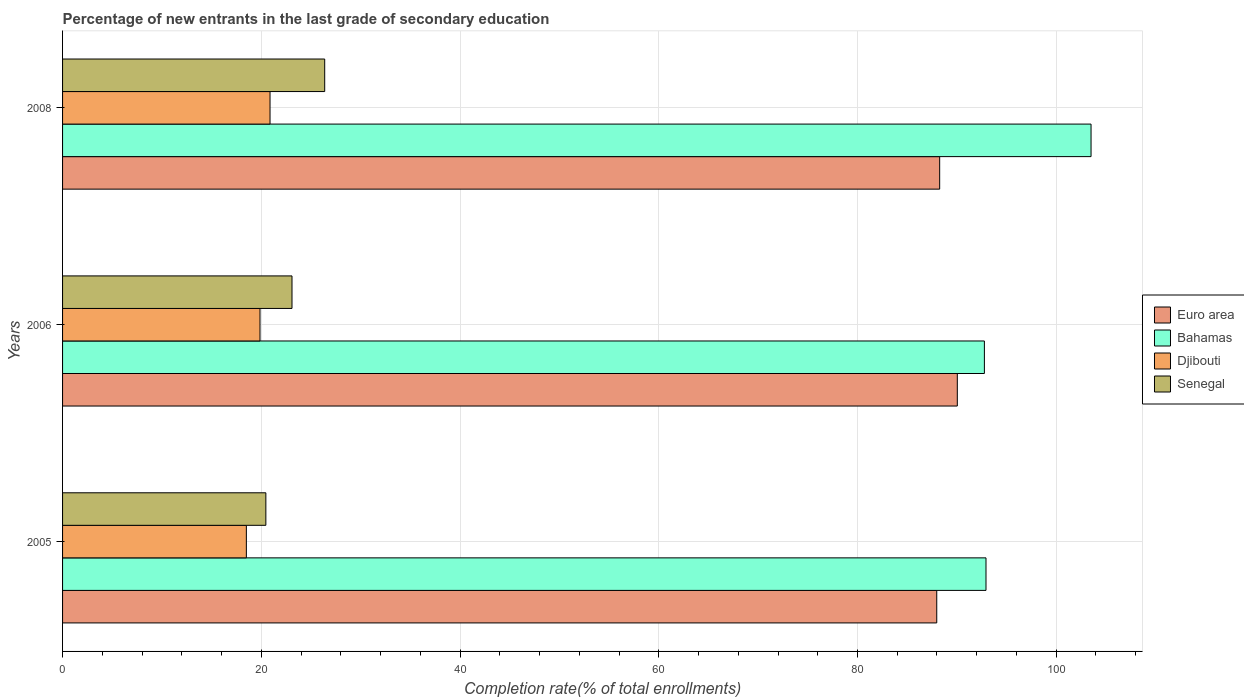How many different coloured bars are there?
Make the answer very short. 4. How many groups of bars are there?
Your response must be concise. 3. Are the number of bars per tick equal to the number of legend labels?
Offer a very short reply. Yes. Are the number of bars on each tick of the Y-axis equal?
Provide a succinct answer. Yes. How many bars are there on the 1st tick from the top?
Provide a short and direct response. 4. How many bars are there on the 3rd tick from the bottom?
Provide a short and direct response. 4. What is the percentage of new entrants in Euro area in 2005?
Give a very brief answer. 87.98. Across all years, what is the maximum percentage of new entrants in Djibouti?
Your response must be concise. 20.88. Across all years, what is the minimum percentage of new entrants in Euro area?
Give a very brief answer. 87.98. What is the total percentage of new entrants in Senegal in the graph?
Keep it short and to the point. 69.93. What is the difference between the percentage of new entrants in Euro area in 2005 and that in 2008?
Ensure brevity in your answer.  -0.29. What is the difference between the percentage of new entrants in Euro area in 2006 and the percentage of new entrants in Djibouti in 2005?
Ensure brevity in your answer.  71.55. What is the average percentage of new entrants in Senegal per year?
Provide a succinct answer. 23.31. In the year 2006, what is the difference between the percentage of new entrants in Euro area and percentage of new entrants in Bahamas?
Give a very brief answer. -2.73. What is the ratio of the percentage of new entrants in Djibouti in 2006 to that in 2008?
Your answer should be compact. 0.95. What is the difference between the highest and the second highest percentage of new entrants in Bahamas?
Keep it short and to the point. 10.57. What is the difference between the highest and the lowest percentage of new entrants in Senegal?
Your response must be concise. 5.92. Is the sum of the percentage of new entrants in Bahamas in 2005 and 2008 greater than the maximum percentage of new entrants in Euro area across all years?
Provide a short and direct response. Yes. Is it the case that in every year, the sum of the percentage of new entrants in Euro area and percentage of new entrants in Senegal is greater than the sum of percentage of new entrants in Bahamas and percentage of new entrants in Djibouti?
Keep it short and to the point. No. What does the 4th bar from the top in 2005 represents?
Offer a terse response. Euro area. What does the 4th bar from the bottom in 2005 represents?
Offer a very short reply. Senegal. How many bars are there?
Keep it short and to the point. 12. Are all the bars in the graph horizontal?
Your answer should be compact. Yes. How many years are there in the graph?
Keep it short and to the point. 3. Where does the legend appear in the graph?
Offer a terse response. Center right. How are the legend labels stacked?
Your response must be concise. Vertical. What is the title of the graph?
Your answer should be very brief. Percentage of new entrants in the last grade of secondary education. What is the label or title of the X-axis?
Your response must be concise. Completion rate(% of total enrollments). What is the label or title of the Y-axis?
Offer a terse response. Years. What is the Completion rate(% of total enrollments) of Euro area in 2005?
Keep it short and to the point. 87.98. What is the Completion rate(% of total enrollments) of Bahamas in 2005?
Your answer should be compact. 92.93. What is the Completion rate(% of total enrollments) in Djibouti in 2005?
Provide a succinct answer. 18.5. What is the Completion rate(% of total enrollments) of Senegal in 2005?
Make the answer very short. 20.46. What is the Completion rate(% of total enrollments) in Euro area in 2006?
Your answer should be very brief. 90.04. What is the Completion rate(% of total enrollments) of Bahamas in 2006?
Provide a short and direct response. 92.77. What is the Completion rate(% of total enrollments) of Djibouti in 2006?
Make the answer very short. 19.87. What is the Completion rate(% of total enrollments) of Senegal in 2006?
Give a very brief answer. 23.09. What is the Completion rate(% of total enrollments) of Euro area in 2008?
Make the answer very short. 88.27. What is the Completion rate(% of total enrollments) in Bahamas in 2008?
Offer a very short reply. 103.5. What is the Completion rate(% of total enrollments) in Djibouti in 2008?
Offer a very short reply. 20.88. What is the Completion rate(% of total enrollments) in Senegal in 2008?
Your answer should be compact. 26.38. Across all years, what is the maximum Completion rate(% of total enrollments) of Euro area?
Make the answer very short. 90.04. Across all years, what is the maximum Completion rate(% of total enrollments) in Bahamas?
Offer a very short reply. 103.5. Across all years, what is the maximum Completion rate(% of total enrollments) in Djibouti?
Provide a short and direct response. 20.88. Across all years, what is the maximum Completion rate(% of total enrollments) of Senegal?
Make the answer very short. 26.38. Across all years, what is the minimum Completion rate(% of total enrollments) in Euro area?
Provide a short and direct response. 87.98. Across all years, what is the minimum Completion rate(% of total enrollments) of Bahamas?
Give a very brief answer. 92.77. Across all years, what is the minimum Completion rate(% of total enrollments) in Djibouti?
Keep it short and to the point. 18.5. Across all years, what is the minimum Completion rate(% of total enrollments) in Senegal?
Keep it short and to the point. 20.46. What is the total Completion rate(% of total enrollments) in Euro area in the graph?
Give a very brief answer. 266.29. What is the total Completion rate(% of total enrollments) of Bahamas in the graph?
Your response must be concise. 289.21. What is the total Completion rate(% of total enrollments) of Djibouti in the graph?
Keep it short and to the point. 59.25. What is the total Completion rate(% of total enrollments) in Senegal in the graph?
Your answer should be very brief. 69.93. What is the difference between the Completion rate(% of total enrollments) of Euro area in 2005 and that in 2006?
Offer a terse response. -2.07. What is the difference between the Completion rate(% of total enrollments) in Bahamas in 2005 and that in 2006?
Offer a terse response. 0.16. What is the difference between the Completion rate(% of total enrollments) of Djibouti in 2005 and that in 2006?
Keep it short and to the point. -1.37. What is the difference between the Completion rate(% of total enrollments) of Senegal in 2005 and that in 2006?
Offer a very short reply. -2.63. What is the difference between the Completion rate(% of total enrollments) in Euro area in 2005 and that in 2008?
Offer a terse response. -0.29. What is the difference between the Completion rate(% of total enrollments) of Bahamas in 2005 and that in 2008?
Make the answer very short. -10.57. What is the difference between the Completion rate(% of total enrollments) in Djibouti in 2005 and that in 2008?
Your answer should be very brief. -2.38. What is the difference between the Completion rate(% of total enrollments) of Senegal in 2005 and that in 2008?
Your response must be concise. -5.92. What is the difference between the Completion rate(% of total enrollments) in Euro area in 2006 and that in 2008?
Provide a succinct answer. 1.77. What is the difference between the Completion rate(% of total enrollments) of Bahamas in 2006 and that in 2008?
Offer a terse response. -10.73. What is the difference between the Completion rate(% of total enrollments) in Djibouti in 2006 and that in 2008?
Provide a succinct answer. -1.01. What is the difference between the Completion rate(% of total enrollments) of Senegal in 2006 and that in 2008?
Your answer should be very brief. -3.29. What is the difference between the Completion rate(% of total enrollments) of Euro area in 2005 and the Completion rate(% of total enrollments) of Bahamas in 2006?
Provide a succinct answer. -4.79. What is the difference between the Completion rate(% of total enrollments) in Euro area in 2005 and the Completion rate(% of total enrollments) in Djibouti in 2006?
Make the answer very short. 68.11. What is the difference between the Completion rate(% of total enrollments) in Euro area in 2005 and the Completion rate(% of total enrollments) in Senegal in 2006?
Your answer should be compact. 64.89. What is the difference between the Completion rate(% of total enrollments) of Bahamas in 2005 and the Completion rate(% of total enrollments) of Djibouti in 2006?
Offer a very short reply. 73.06. What is the difference between the Completion rate(% of total enrollments) in Bahamas in 2005 and the Completion rate(% of total enrollments) in Senegal in 2006?
Offer a very short reply. 69.84. What is the difference between the Completion rate(% of total enrollments) in Djibouti in 2005 and the Completion rate(% of total enrollments) in Senegal in 2006?
Your response must be concise. -4.59. What is the difference between the Completion rate(% of total enrollments) of Euro area in 2005 and the Completion rate(% of total enrollments) of Bahamas in 2008?
Make the answer very short. -15.53. What is the difference between the Completion rate(% of total enrollments) of Euro area in 2005 and the Completion rate(% of total enrollments) of Djibouti in 2008?
Your answer should be very brief. 67.1. What is the difference between the Completion rate(% of total enrollments) of Euro area in 2005 and the Completion rate(% of total enrollments) of Senegal in 2008?
Offer a very short reply. 61.6. What is the difference between the Completion rate(% of total enrollments) in Bahamas in 2005 and the Completion rate(% of total enrollments) in Djibouti in 2008?
Make the answer very short. 72.05. What is the difference between the Completion rate(% of total enrollments) of Bahamas in 2005 and the Completion rate(% of total enrollments) of Senegal in 2008?
Your answer should be very brief. 66.55. What is the difference between the Completion rate(% of total enrollments) of Djibouti in 2005 and the Completion rate(% of total enrollments) of Senegal in 2008?
Your answer should be very brief. -7.88. What is the difference between the Completion rate(% of total enrollments) of Euro area in 2006 and the Completion rate(% of total enrollments) of Bahamas in 2008?
Your answer should be very brief. -13.46. What is the difference between the Completion rate(% of total enrollments) in Euro area in 2006 and the Completion rate(% of total enrollments) in Djibouti in 2008?
Provide a short and direct response. 69.17. What is the difference between the Completion rate(% of total enrollments) in Euro area in 2006 and the Completion rate(% of total enrollments) in Senegal in 2008?
Offer a terse response. 63.66. What is the difference between the Completion rate(% of total enrollments) of Bahamas in 2006 and the Completion rate(% of total enrollments) of Djibouti in 2008?
Your response must be concise. 71.89. What is the difference between the Completion rate(% of total enrollments) in Bahamas in 2006 and the Completion rate(% of total enrollments) in Senegal in 2008?
Provide a succinct answer. 66.39. What is the difference between the Completion rate(% of total enrollments) in Djibouti in 2006 and the Completion rate(% of total enrollments) in Senegal in 2008?
Make the answer very short. -6.51. What is the average Completion rate(% of total enrollments) in Euro area per year?
Provide a succinct answer. 88.76. What is the average Completion rate(% of total enrollments) in Bahamas per year?
Keep it short and to the point. 96.4. What is the average Completion rate(% of total enrollments) in Djibouti per year?
Ensure brevity in your answer.  19.75. What is the average Completion rate(% of total enrollments) of Senegal per year?
Offer a terse response. 23.31. In the year 2005, what is the difference between the Completion rate(% of total enrollments) in Euro area and Completion rate(% of total enrollments) in Bahamas?
Keep it short and to the point. -4.96. In the year 2005, what is the difference between the Completion rate(% of total enrollments) in Euro area and Completion rate(% of total enrollments) in Djibouti?
Provide a short and direct response. 69.48. In the year 2005, what is the difference between the Completion rate(% of total enrollments) in Euro area and Completion rate(% of total enrollments) in Senegal?
Offer a very short reply. 67.52. In the year 2005, what is the difference between the Completion rate(% of total enrollments) in Bahamas and Completion rate(% of total enrollments) in Djibouti?
Your answer should be very brief. 74.44. In the year 2005, what is the difference between the Completion rate(% of total enrollments) in Bahamas and Completion rate(% of total enrollments) in Senegal?
Make the answer very short. 72.47. In the year 2005, what is the difference between the Completion rate(% of total enrollments) in Djibouti and Completion rate(% of total enrollments) in Senegal?
Your answer should be very brief. -1.96. In the year 2006, what is the difference between the Completion rate(% of total enrollments) of Euro area and Completion rate(% of total enrollments) of Bahamas?
Offer a terse response. -2.73. In the year 2006, what is the difference between the Completion rate(% of total enrollments) in Euro area and Completion rate(% of total enrollments) in Djibouti?
Provide a succinct answer. 70.17. In the year 2006, what is the difference between the Completion rate(% of total enrollments) in Euro area and Completion rate(% of total enrollments) in Senegal?
Give a very brief answer. 66.96. In the year 2006, what is the difference between the Completion rate(% of total enrollments) of Bahamas and Completion rate(% of total enrollments) of Djibouti?
Your response must be concise. 72.9. In the year 2006, what is the difference between the Completion rate(% of total enrollments) in Bahamas and Completion rate(% of total enrollments) in Senegal?
Provide a succinct answer. 69.68. In the year 2006, what is the difference between the Completion rate(% of total enrollments) in Djibouti and Completion rate(% of total enrollments) in Senegal?
Ensure brevity in your answer.  -3.22. In the year 2008, what is the difference between the Completion rate(% of total enrollments) in Euro area and Completion rate(% of total enrollments) in Bahamas?
Give a very brief answer. -15.23. In the year 2008, what is the difference between the Completion rate(% of total enrollments) in Euro area and Completion rate(% of total enrollments) in Djibouti?
Provide a short and direct response. 67.39. In the year 2008, what is the difference between the Completion rate(% of total enrollments) in Euro area and Completion rate(% of total enrollments) in Senegal?
Keep it short and to the point. 61.89. In the year 2008, what is the difference between the Completion rate(% of total enrollments) of Bahamas and Completion rate(% of total enrollments) of Djibouti?
Offer a terse response. 82.63. In the year 2008, what is the difference between the Completion rate(% of total enrollments) in Bahamas and Completion rate(% of total enrollments) in Senegal?
Your answer should be very brief. 77.12. In the year 2008, what is the difference between the Completion rate(% of total enrollments) in Djibouti and Completion rate(% of total enrollments) in Senegal?
Your answer should be very brief. -5.5. What is the ratio of the Completion rate(% of total enrollments) in Euro area in 2005 to that in 2006?
Give a very brief answer. 0.98. What is the ratio of the Completion rate(% of total enrollments) of Djibouti in 2005 to that in 2006?
Your answer should be compact. 0.93. What is the ratio of the Completion rate(% of total enrollments) of Senegal in 2005 to that in 2006?
Keep it short and to the point. 0.89. What is the ratio of the Completion rate(% of total enrollments) in Bahamas in 2005 to that in 2008?
Your answer should be very brief. 0.9. What is the ratio of the Completion rate(% of total enrollments) of Djibouti in 2005 to that in 2008?
Offer a very short reply. 0.89. What is the ratio of the Completion rate(% of total enrollments) in Senegal in 2005 to that in 2008?
Your answer should be very brief. 0.78. What is the ratio of the Completion rate(% of total enrollments) in Euro area in 2006 to that in 2008?
Offer a terse response. 1.02. What is the ratio of the Completion rate(% of total enrollments) of Bahamas in 2006 to that in 2008?
Your response must be concise. 0.9. What is the ratio of the Completion rate(% of total enrollments) in Djibouti in 2006 to that in 2008?
Keep it short and to the point. 0.95. What is the ratio of the Completion rate(% of total enrollments) of Senegal in 2006 to that in 2008?
Offer a very short reply. 0.88. What is the difference between the highest and the second highest Completion rate(% of total enrollments) of Euro area?
Provide a succinct answer. 1.77. What is the difference between the highest and the second highest Completion rate(% of total enrollments) of Bahamas?
Offer a very short reply. 10.57. What is the difference between the highest and the second highest Completion rate(% of total enrollments) of Djibouti?
Provide a short and direct response. 1.01. What is the difference between the highest and the second highest Completion rate(% of total enrollments) in Senegal?
Your answer should be very brief. 3.29. What is the difference between the highest and the lowest Completion rate(% of total enrollments) in Euro area?
Ensure brevity in your answer.  2.07. What is the difference between the highest and the lowest Completion rate(% of total enrollments) of Bahamas?
Ensure brevity in your answer.  10.73. What is the difference between the highest and the lowest Completion rate(% of total enrollments) of Djibouti?
Ensure brevity in your answer.  2.38. What is the difference between the highest and the lowest Completion rate(% of total enrollments) in Senegal?
Keep it short and to the point. 5.92. 